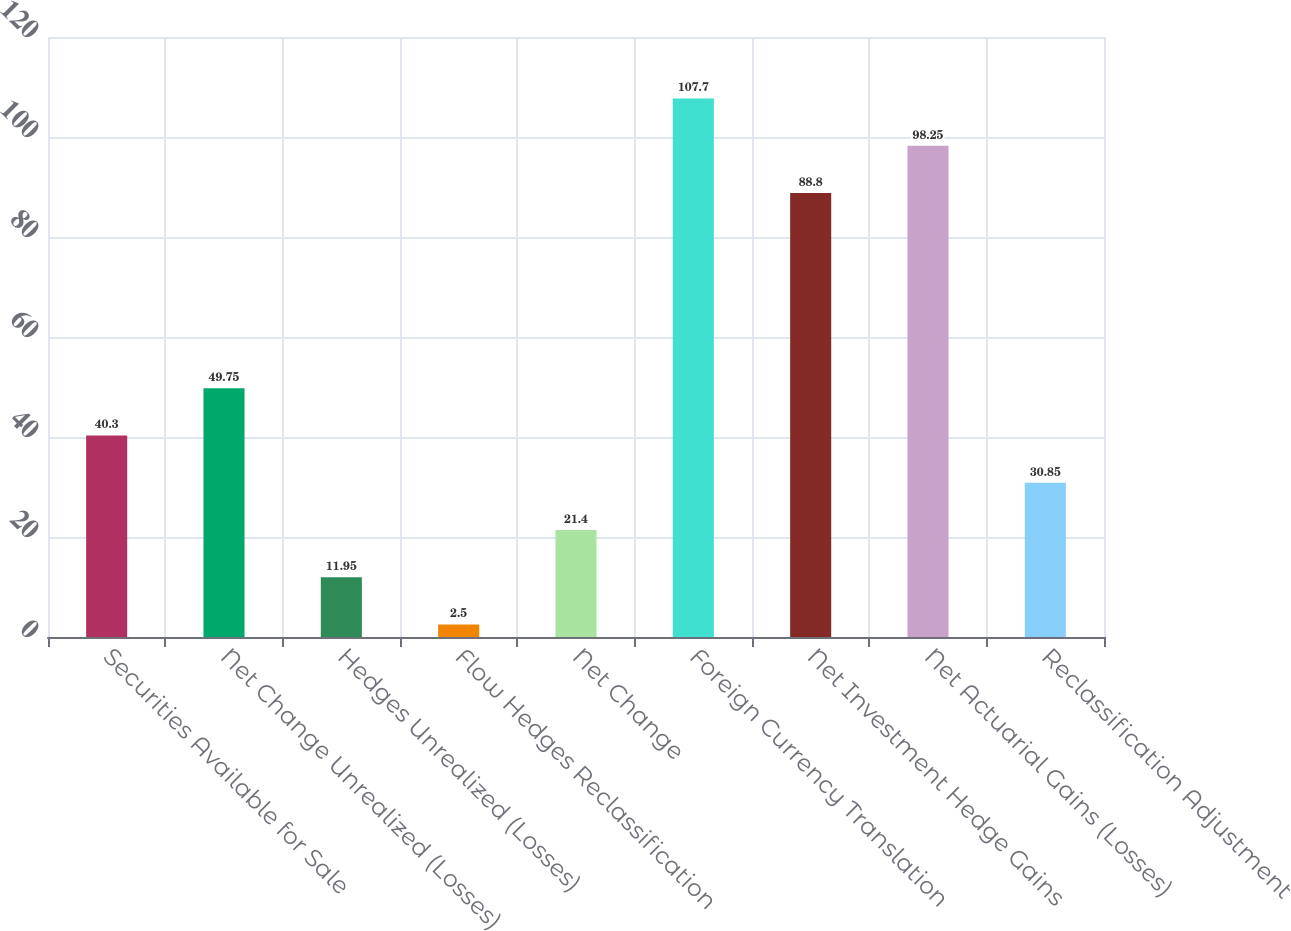Convert chart. <chart><loc_0><loc_0><loc_500><loc_500><bar_chart><fcel>Securities Available for Sale<fcel>Net Change Unrealized (Losses)<fcel>Hedges Unrealized (Losses)<fcel>Flow Hedges Reclassification<fcel>Net Change<fcel>Foreign Currency Translation<fcel>Net Investment Hedge Gains<fcel>Net Actuarial Gains (Losses)<fcel>Reclassification Adjustment<nl><fcel>40.3<fcel>49.75<fcel>11.95<fcel>2.5<fcel>21.4<fcel>107.7<fcel>88.8<fcel>98.25<fcel>30.85<nl></chart> 